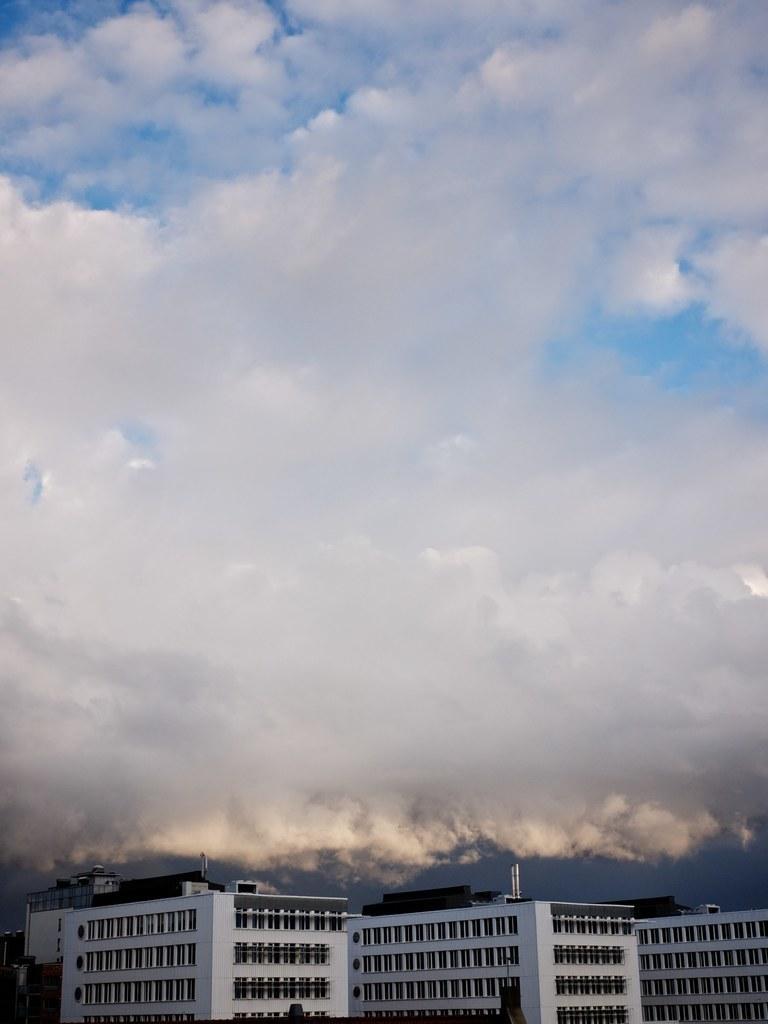Please provide a concise description of this image. This image consists of buildings along with windows. At the top, there are clouds in the sky. 